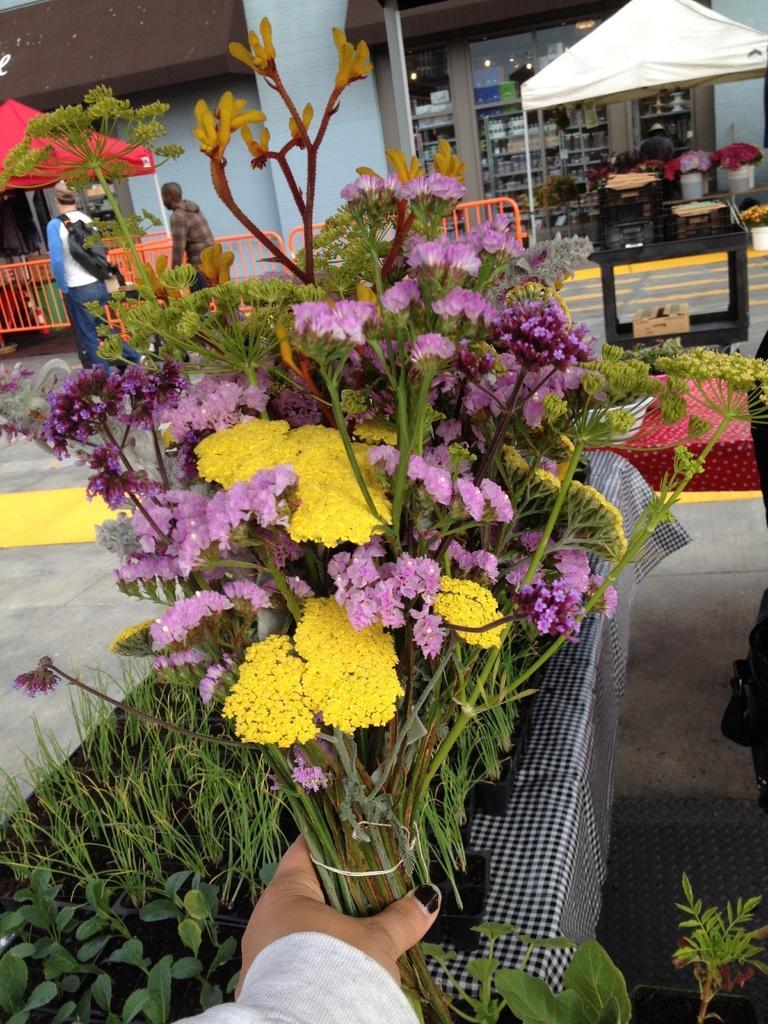Please provide a concise description of this image. This image is taken outdoors. In the background there is a building. There are two tents and there are few objects. There is a railing. Two men are standing on the floor. There is a table. In the middle of the image there is a bouquet in the hand of a person. There is a table with a tablecloth and many plants in the pots on it. 